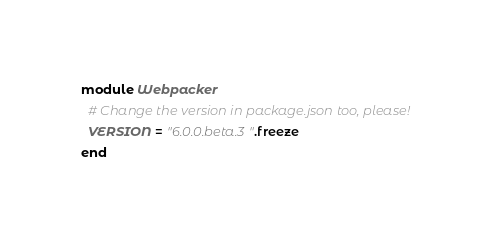Convert code to text. <code><loc_0><loc_0><loc_500><loc_500><_Ruby_>module Webpacker
  # Change the version in package.json too, please!
  VERSION = "6.0.0.beta.3".freeze
end
</code> 